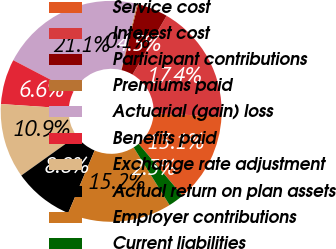Convert chart to OTSL. <chart><loc_0><loc_0><loc_500><loc_500><pie_chart><fcel>Service cost<fcel>Interest cost<fcel>Participant contributions<fcel>Premiums paid<fcel>Actuarial (gain) loss<fcel>Benefits paid<fcel>Exchange rate adjustment<fcel>Actual return on plan assets<fcel>Employer contributions<fcel>Current liabilities<nl><fcel>13.08%<fcel>17.39%<fcel>4.46%<fcel>0.15%<fcel>21.1%<fcel>6.61%<fcel>10.92%<fcel>8.77%<fcel>15.23%<fcel>2.3%<nl></chart> 